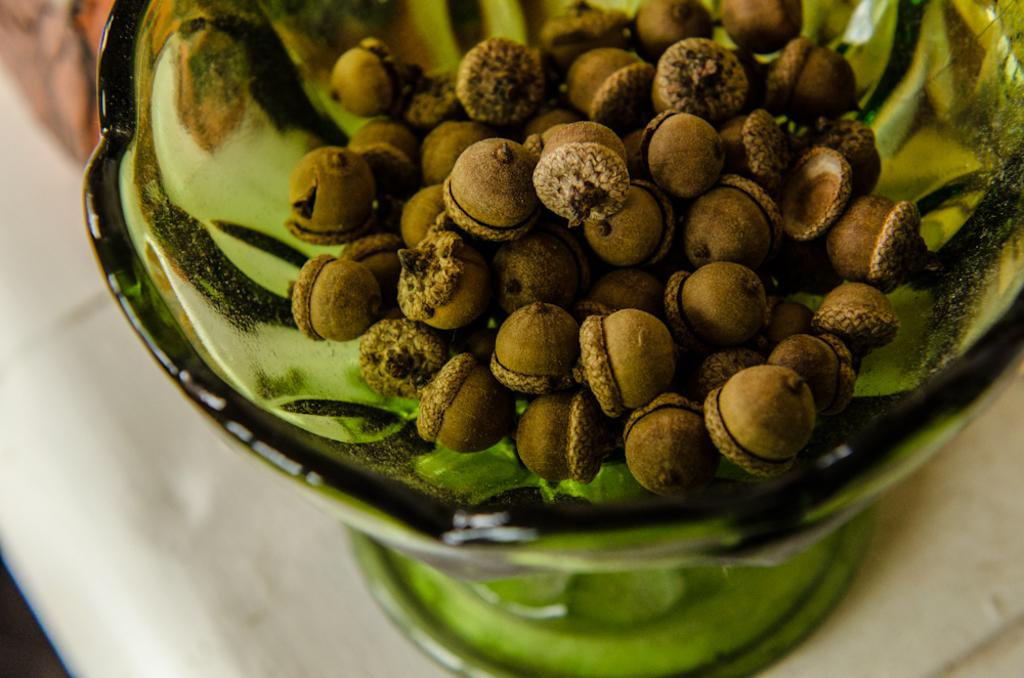What type of food item is present in the image? There are brown color nuts in the image. Where are the nuts located? The nuts are in a bowl. On what surface is the bowl placed? The bowl is placed on a table. What scientific discovery is being made in the image? There is no scientific discovery or activity present in the image; it features a bowl of nuts on a table. 